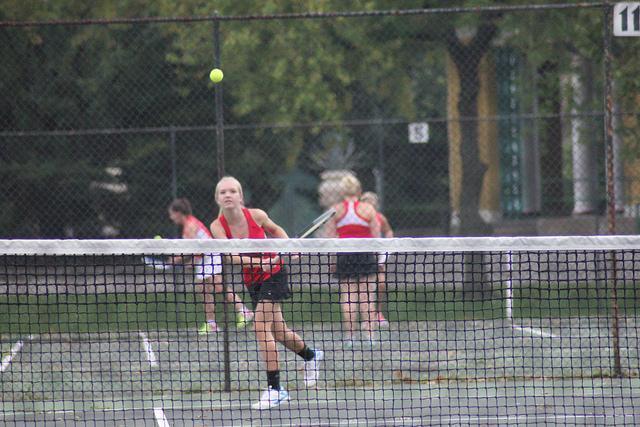How many people are there?
Give a very brief answer. 4. 